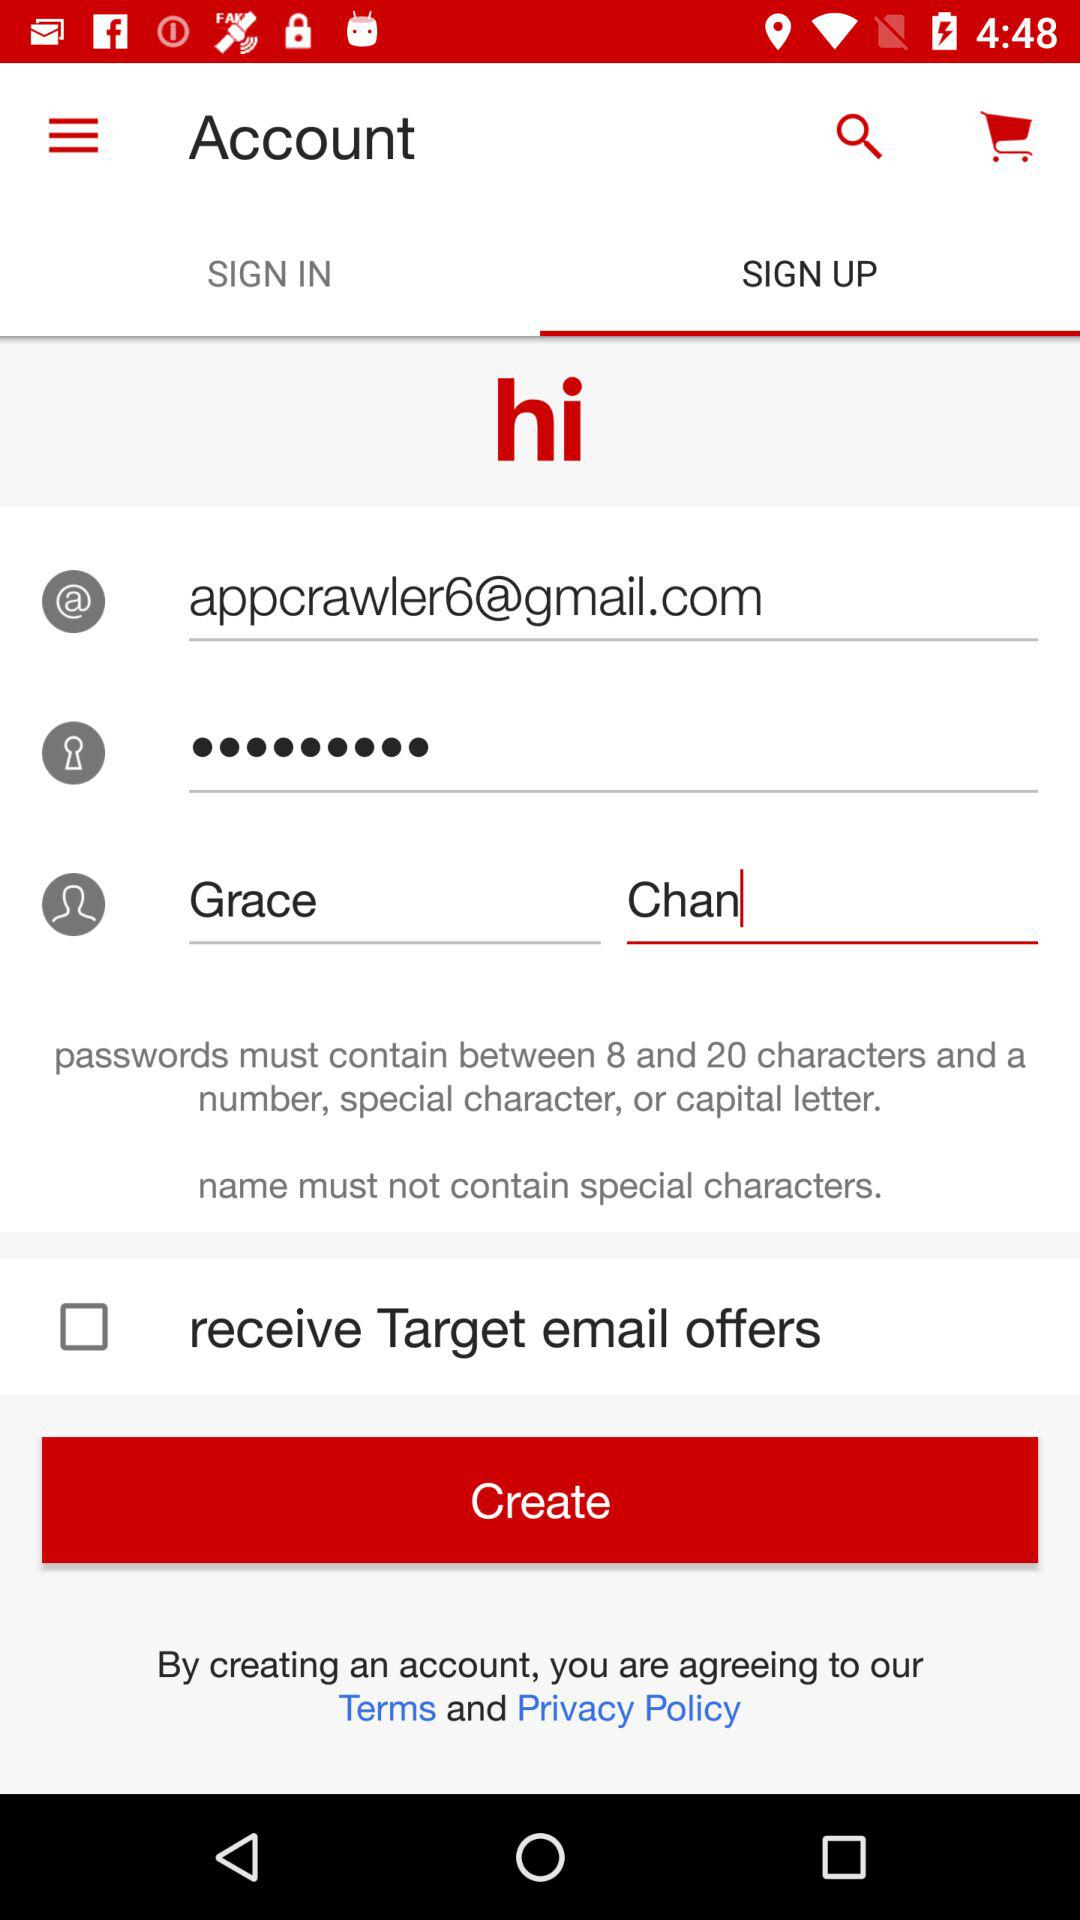Which tab is selected? The selected tab is "SIGN UP". 